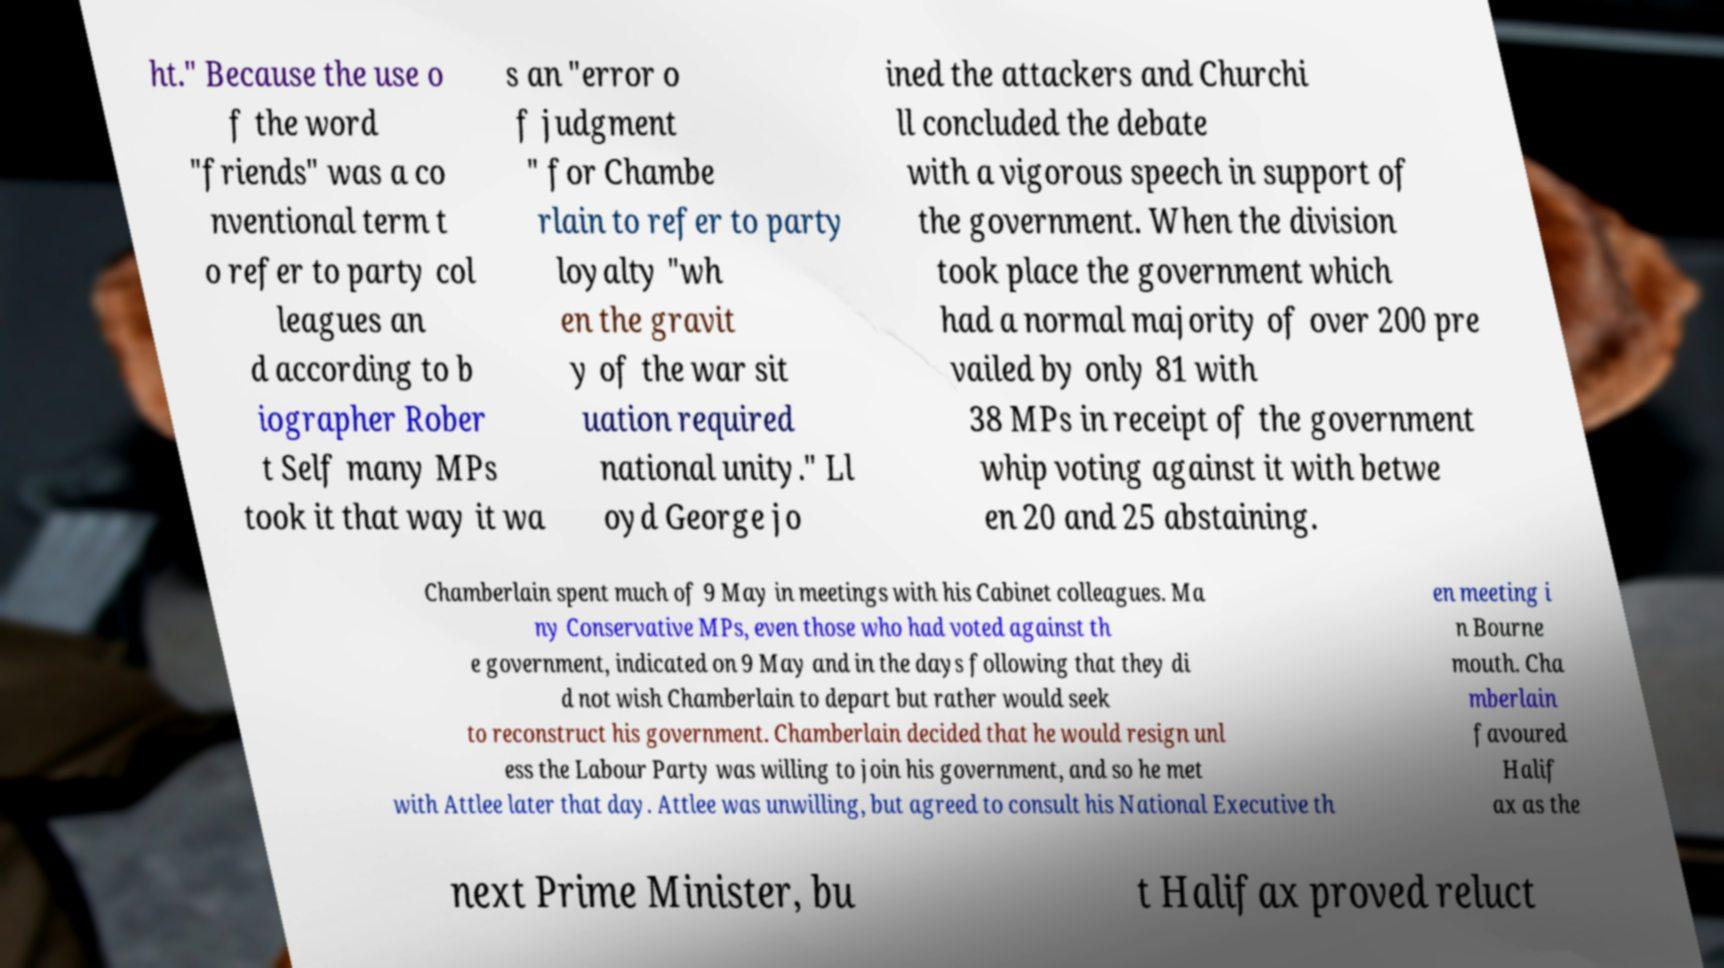Please read and relay the text visible in this image. What does it say? ht." Because the use o f the word "friends" was a co nventional term t o refer to party col leagues an d according to b iographer Rober t Self many MPs took it that way it wa s an "error o f judgment " for Chambe rlain to refer to party loyalty "wh en the gravit y of the war sit uation required national unity." Ll oyd George jo ined the attackers and Churchi ll concluded the debate with a vigorous speech in support of the government. When the division took place the government which had a normal majority of over 200 pre vailed by only 81 with 38 MPs in receipt of the government whip voting against it with betwe en 20 and 25 abstaining. Chamberlain spent much of 9 May in meetings with his Cabinet colleagues. Ma ny Conservative MPs, even those who had voted against th e government, indicated on 9 May and in the days following that they di d not wish Chamberlain to depart but rather would seek to reconstruct his government. Chamberlain decided that he would resign unl ess the Labour Party was willing to join his government, and so he met with Attlee later that day. Attlee was unwilling, but agreed to consult his National Executive th en meeting i n Bourne mouth. Cha mberlain favoured Halif ax as the next Prime Minister, bu t Halifax proved reluct 